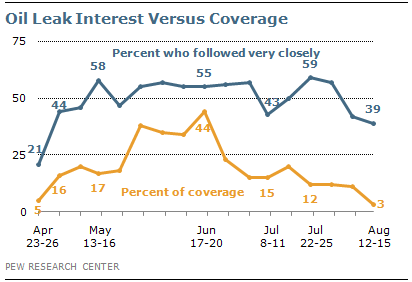Highlight a few significant elements in this photo. If the value of one graph is consistently higher than the other, the graph with the higher value is typically depicted in blue. The peak value of the orange graph is less than the peak value of the blue graph. 